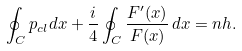<formula> <loc_0><loc_0><loc_500><loc_500>\oint _ { C } p _ { c l } d x + \frac { i } { 4 } \oint _ { C } \frac { F ^ { \prime } ( x ) } { F ( x ) } \, d x = n h .</formula> 